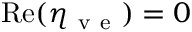Convert formula to latex. <formula><loc_0><loc_0><loc_500><loc_500>R e ( \eta _ { v e } ) = 0</formula> 